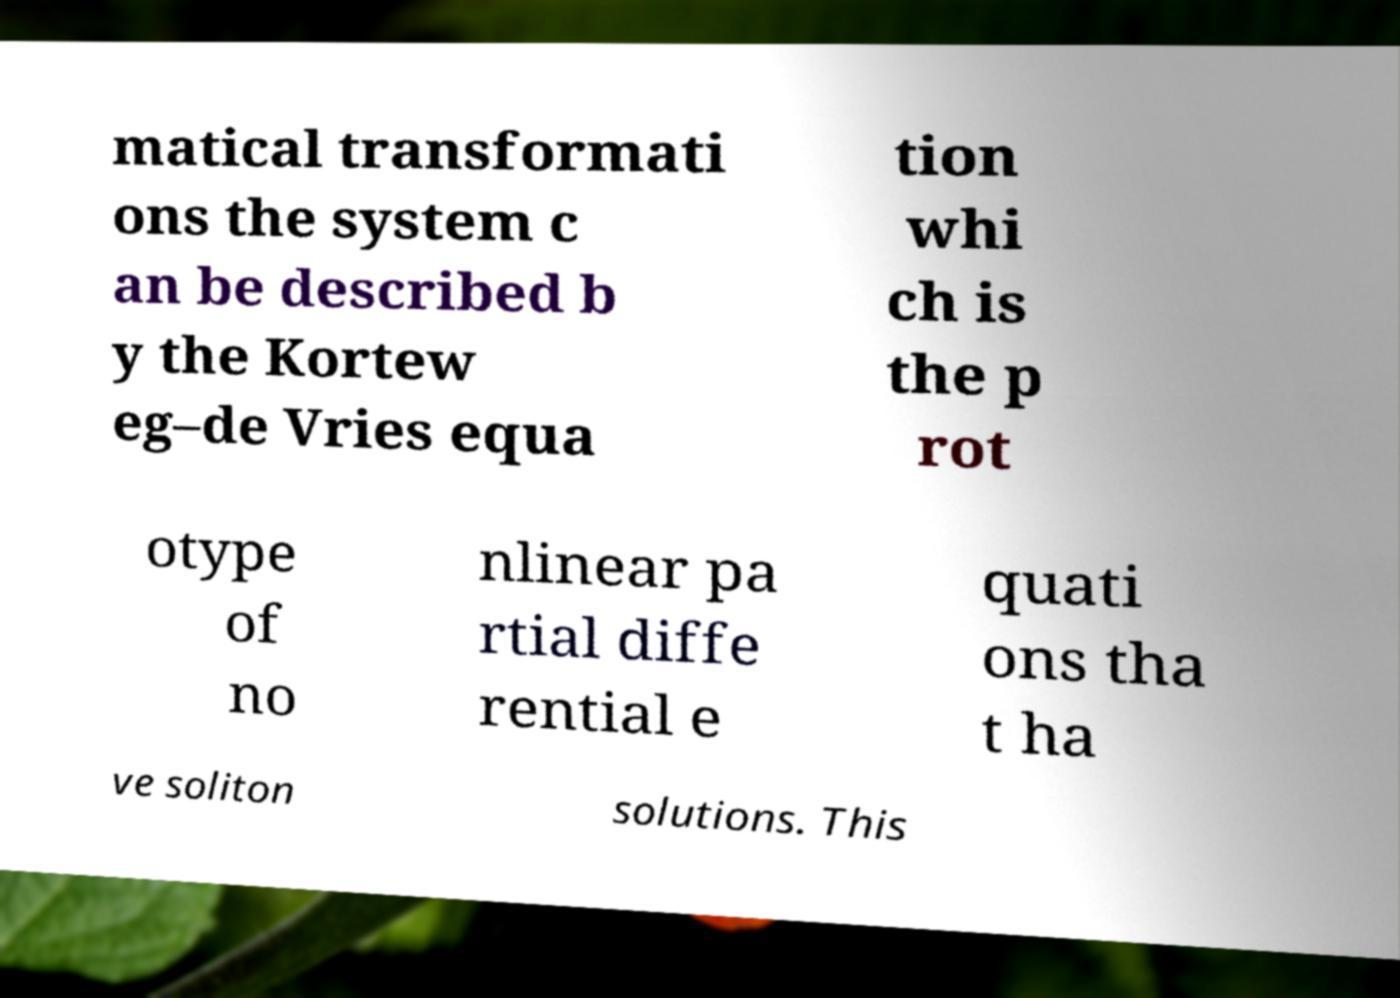There's text embedded in this image that I need extracted. Can you transcribe it verbatim? matical transformati ons the system c an be described b y the Kortew eg–de Vries equa tion whi ch is the p rot otype of no nlinear pa rtial diffe rential e quati ons tha t ha ve soliton solutions. This 